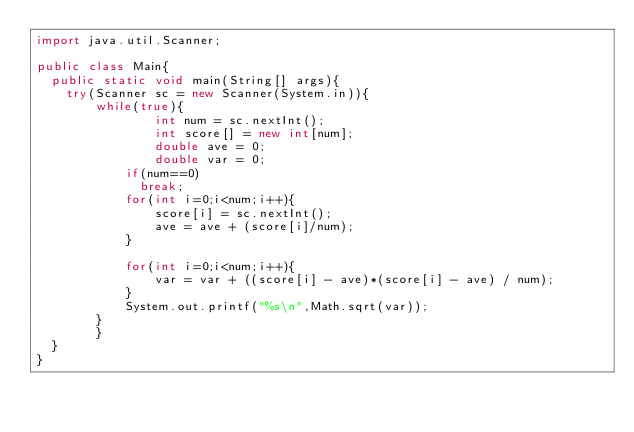Convert code to text. <code><loc_0><loc_0><loc_500><loc_500><_Java_>import java.util.Scanner;

public class Main{
  public static void main(String[] args){
    try(Scanner sc = new Scanner(System.in)){
        while(true){
                int num = sc.nextInt();
                int score[] = new int[num];
                double ave = 0;
                double var = 0;
            if(num==0)
              break;
            for(int i=0;i<num;i++){
                score[i] = sc.nextInt();
                ave = ave + (score[i]/num);
            }

            for(int i=0;i<num;i++){
                var = var + ((score[i] - ave)*(score[i] - ave) / num);
            }
            System.out.printf("%s\n",Math.sqrt(var));
        }
        }
  }
}

</code> 